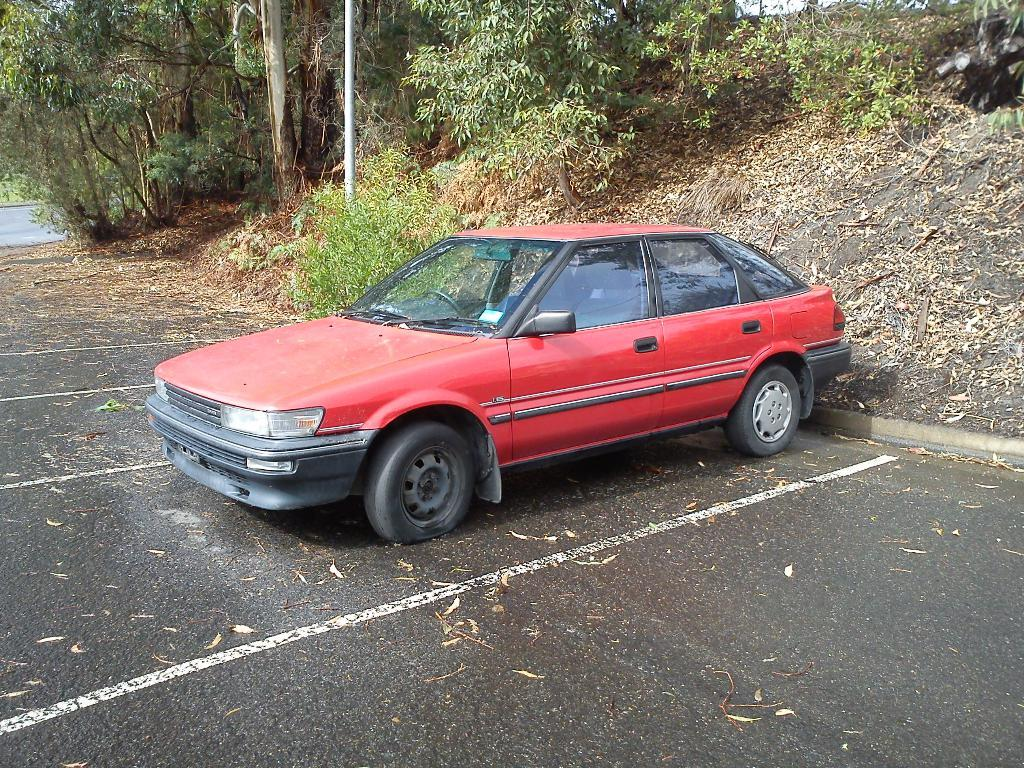What is the main subject of the image? The main subject of the image is a car. Where is the car located in the image? The car is on the road in the image. What can be seen in the background of the image? There are trees and poles in the background of the image. What type of harmony can be heard in the image? There is no audible sound in the image, so it is not possible to determine if any harmony can be heard. 